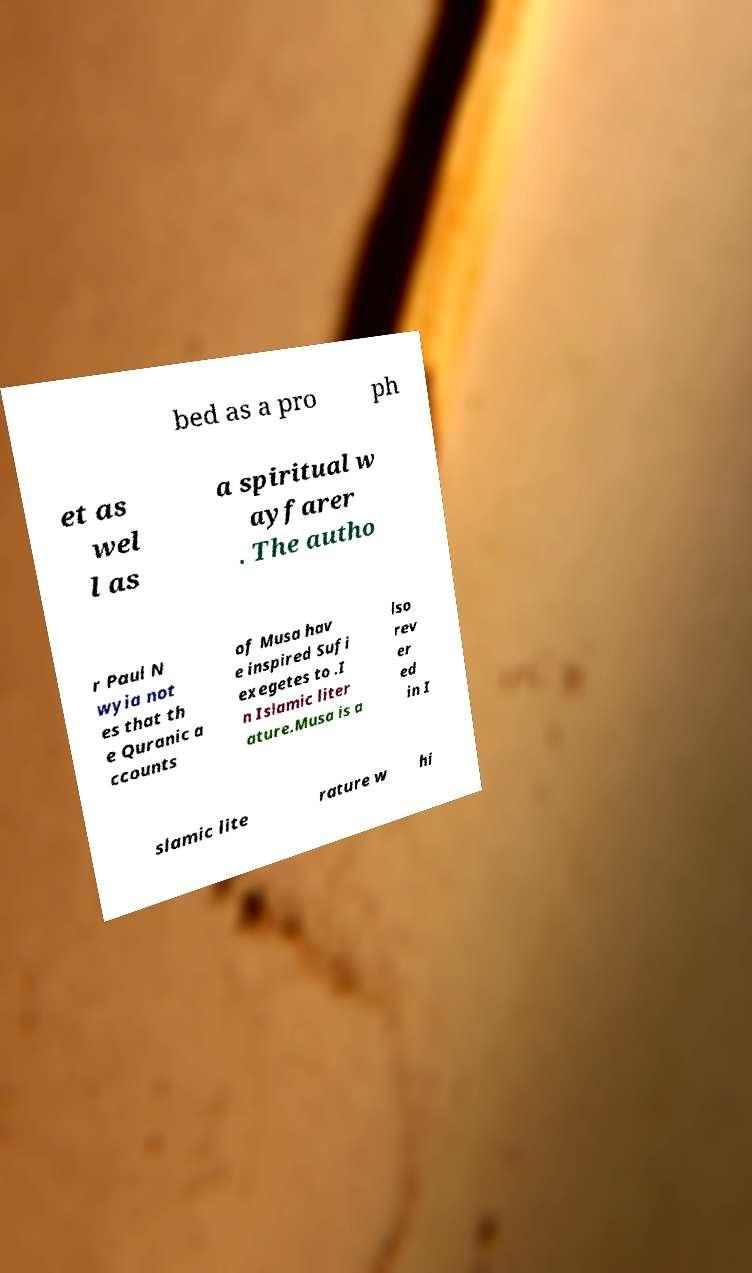Can you read and provide the text displayed in the image?This photo seems to have some interesting text. Can you extract and type it out for me? bed as a pro ph et as wel l as a spiritual w ayfarer . The autho r Paul N wyia not es that th e Quranic a ccounts of Musa hav e inspired Sufi exegetes to .I n Islamic liter ature.Musa is a lso rev er ed in I slamic lite rature w hi 